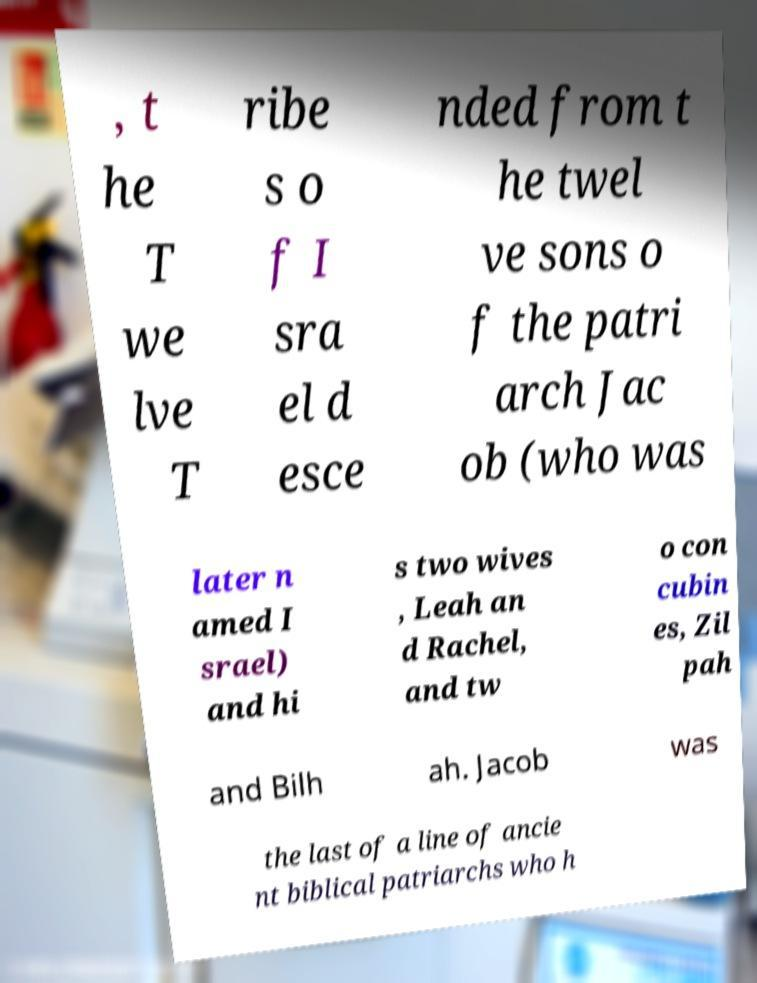Please read and relay the text visible in this image. What does it say? , t he T we lve T ribe s o f I sra el d esce nded from t he twel ve sons o f the patri arch Jac ob (who was later n amed I srael) and hi s two wives , Leah an d Rachel, and tw o con cubin es, Zil pah and Bilh ah. Jacob was the last of a line of ancie nt biblical patriarchs who h 